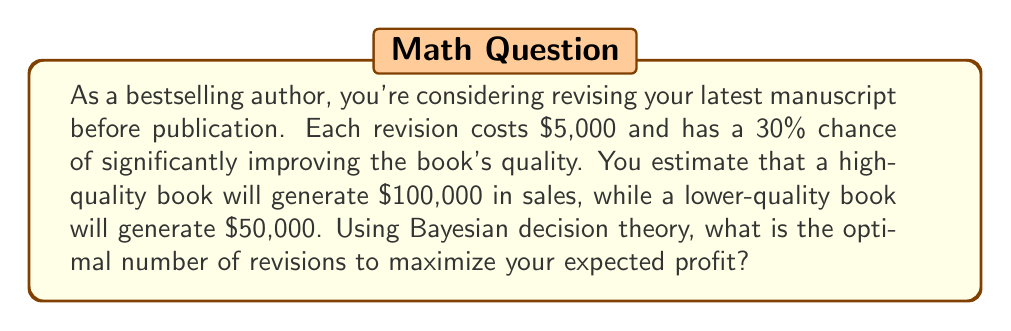Can you solve this math problem? Let's approach this problem using Bayesian decision theory:

1) First, we need to define our variables:
   $r$ = number of revisions
   $c$ = cost per revision = $5,000
   $p$ = probability of improvement per revision = 0.3
   $H$ = revenue from high-quality book = $100,000
   $L$ = revenue from low-quality book = $50,000

2) The probability of the book being high quality after $r$ revisions is:
   $P(H|r) = 1 - (1-p)^r$

3) The expected revenue after $r$ revisions is:
   $E(R|r) = H \cdot P(H|r) + L \cdot (1-P(H|r))$

4) The total cost of revisions is:
   $C(r) = c \cdot r$

5) The expected profit is:
   $E(P|r) = E(R|r) - C(r)$

6) Substituting our values:
   $E(P|r) = 100000 \cdot (1-(0.7)^r) + 50000 \cdot (0.7)^r - 5000r$

7) To find the optimal number of revisions, we need to find the maximum of this function. We can do this by taking the derivative with respect to $r$ and setting it to zero:

   $\frac{d}{dr}E(P|r) = -50000 \cdot \ln(0.7) \cdot (0.7)^r - 5000 = 0$

8) Solving this equation:
   $(0.7)^r = \frac{5000}{50000 \cdot \ln(0.7)} \approx 0.2056$

   $r = \frac{\ln(0.2056)}{\ln(0.7)} \approx 2.37$

9) Since we can only do a whole number of revisions, we need to check $r=2$ and $r=3$:

   $E(P|2) = 100000 \cdot (1-(0.7)^2) + 50000 \cdot (0.7)^2 - 5000 \cdot 2 = 69,550$
   $E(P|3) = 100000 \cdot (1-(0.7)^3) + 50000 \cdot (0.7)^3 - 5000 \cdot 3 = 70,235$

Therefore, the optimal number of revisions is 3.
Answer: The optimal number of revisions to maximize expected profit is 3. 